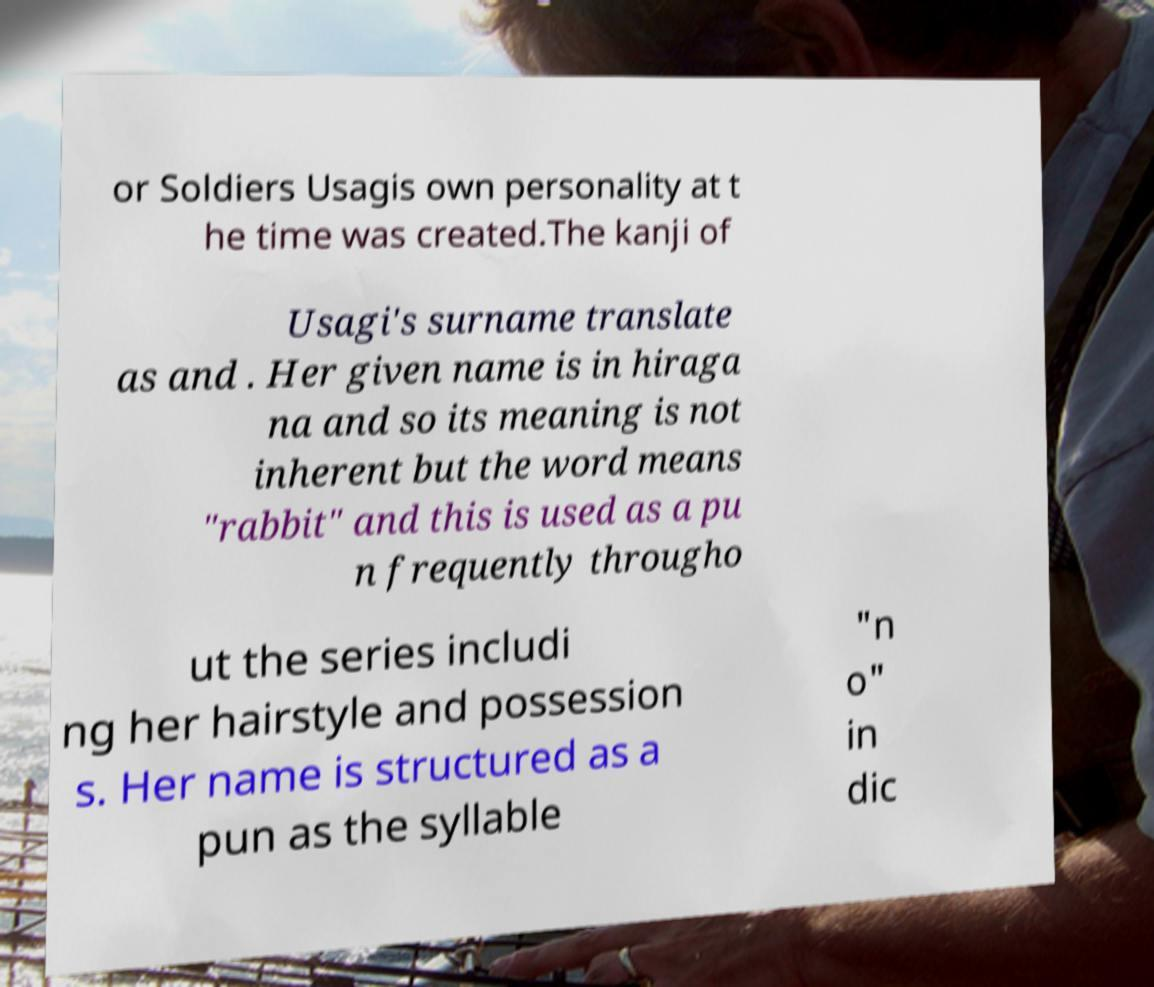What messages or text are displayed in this image? I need them in a readable, typed format. or Soldiers Usagis own personality at t he time was created.The kanji of Usagi's surname translate as and . Her given name is in hiraga na and so its meaning is not inherent but the word means "rabbit" and this is used as a pu n frequently througho ut the series includi ng her hairstyle and possession s. Her name is structured as a pun as the syllable "n o" in dic 